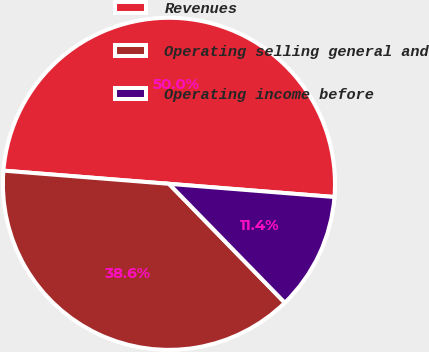Convert chart. <chart><loc_0><loc_0><loc_500><loc_500><pie_chart><fcel>Revenues<fcel>Operating selling general and<fcel>Operating income before<nl><fcel>50.0%<fcel>38.56%<fcel>11.44%<nl></chart> 